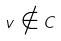Convert formula to latex. <formula><loc_0><loc_0><loc_500><loc_500>v \notin C</formula> 